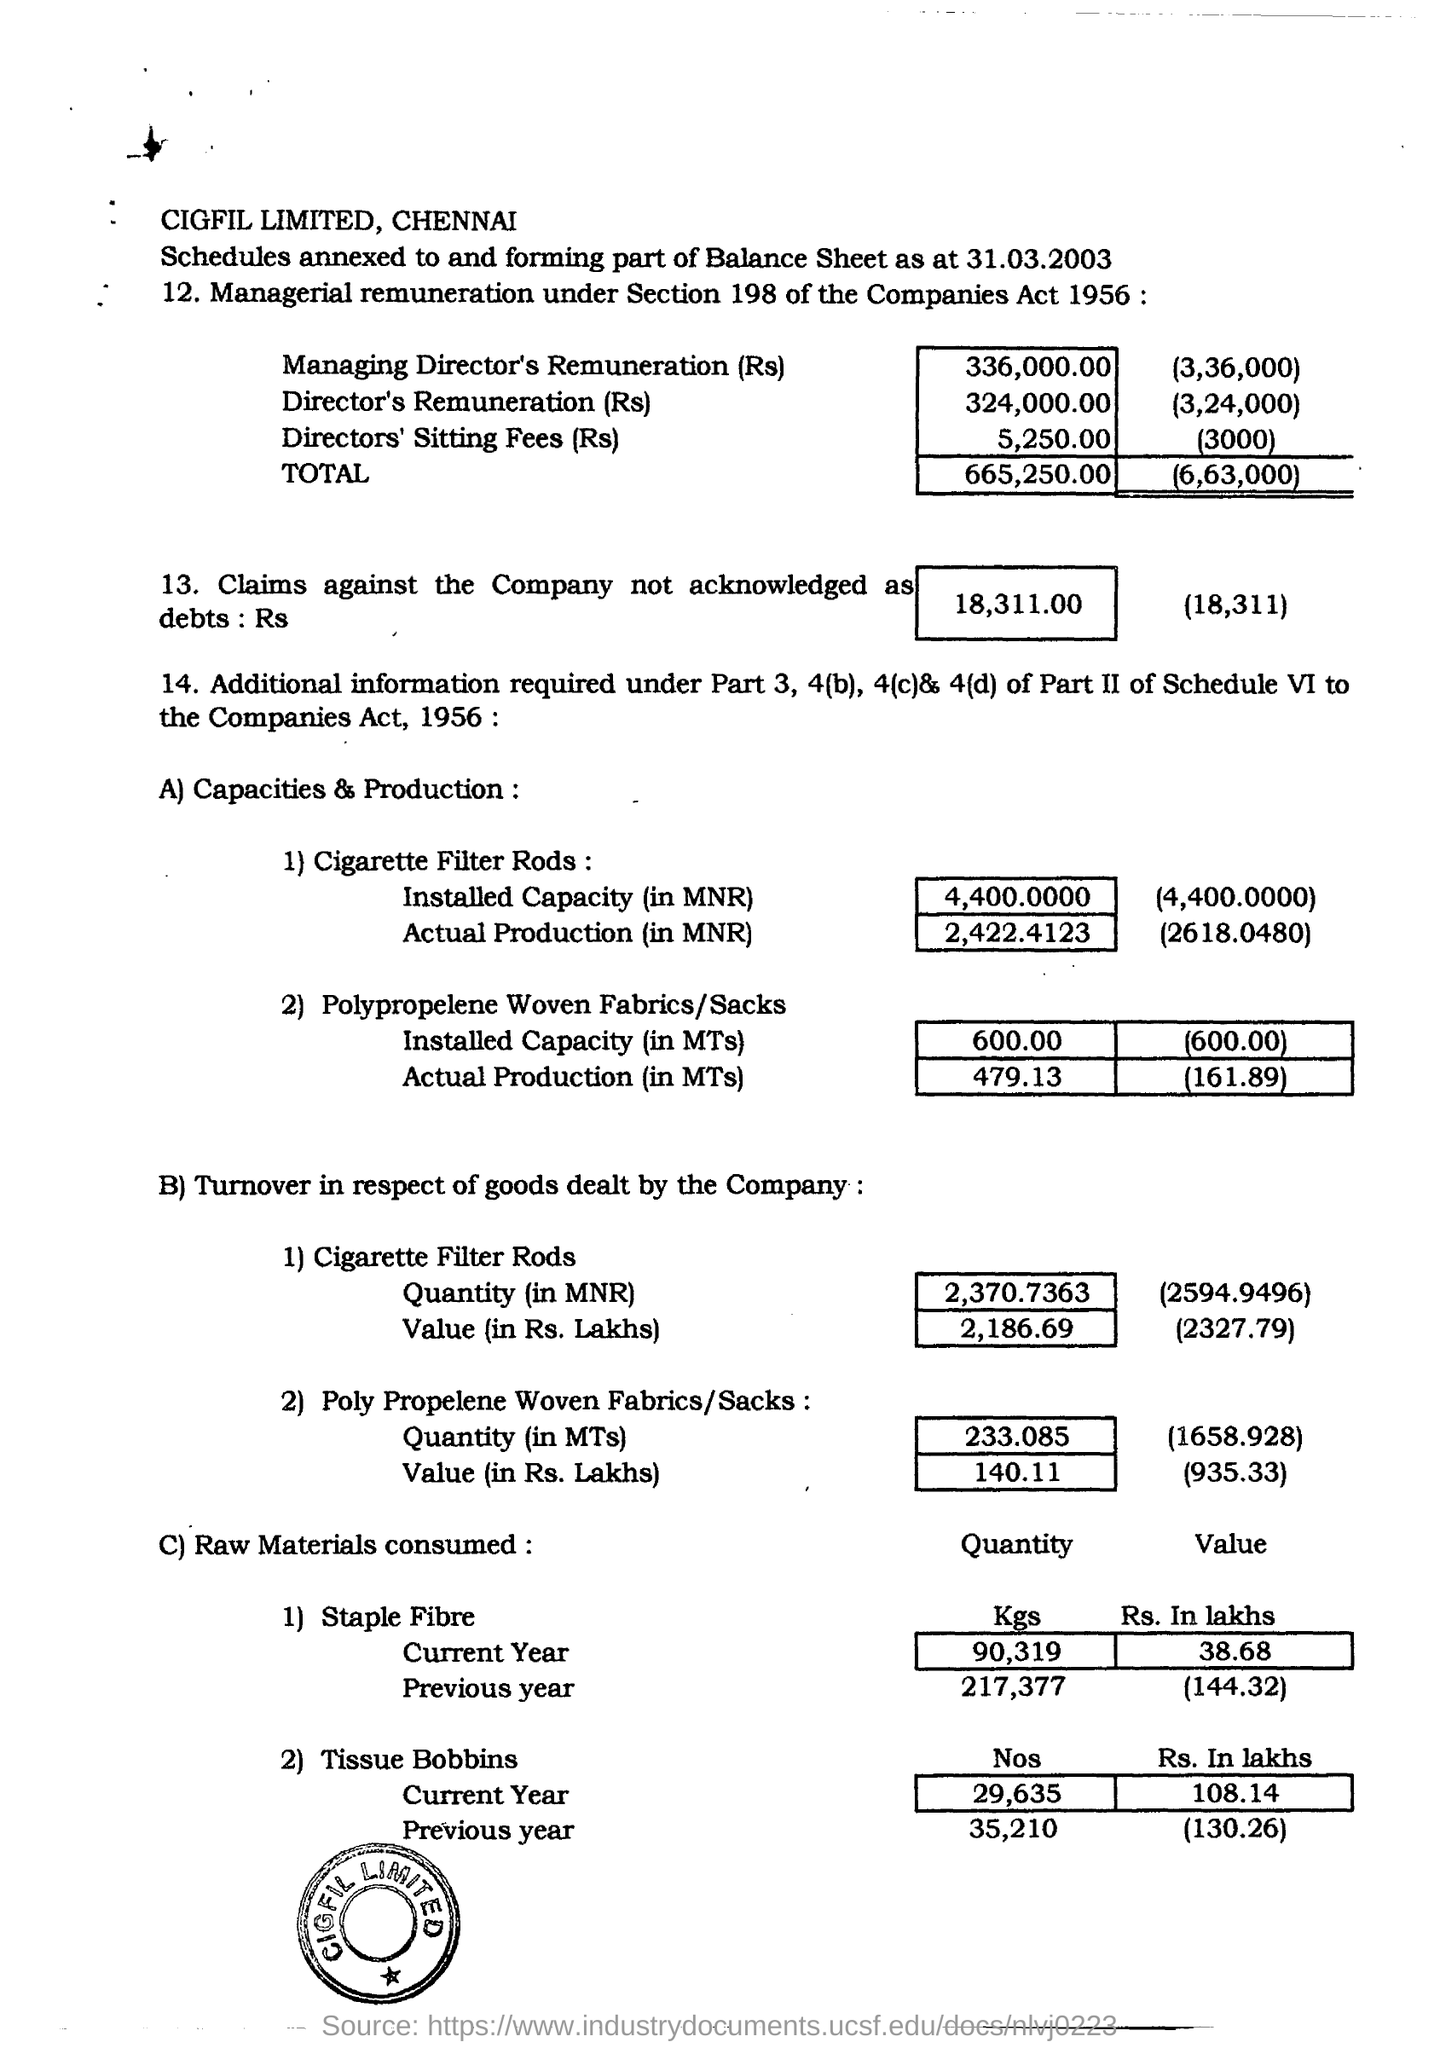Highlight a few significant elements in this photo. The current year has used a total of 29,635 tissue bobbins. The installed capacity for cigarette filter rods is 4,400,000 MNR. According to the information provided, a claim of 18,311.00 rupees has been made against the company, but it has not yet been acknowledged as debt. The actual production of cigarette filter rods was 2,422.4123 units. 